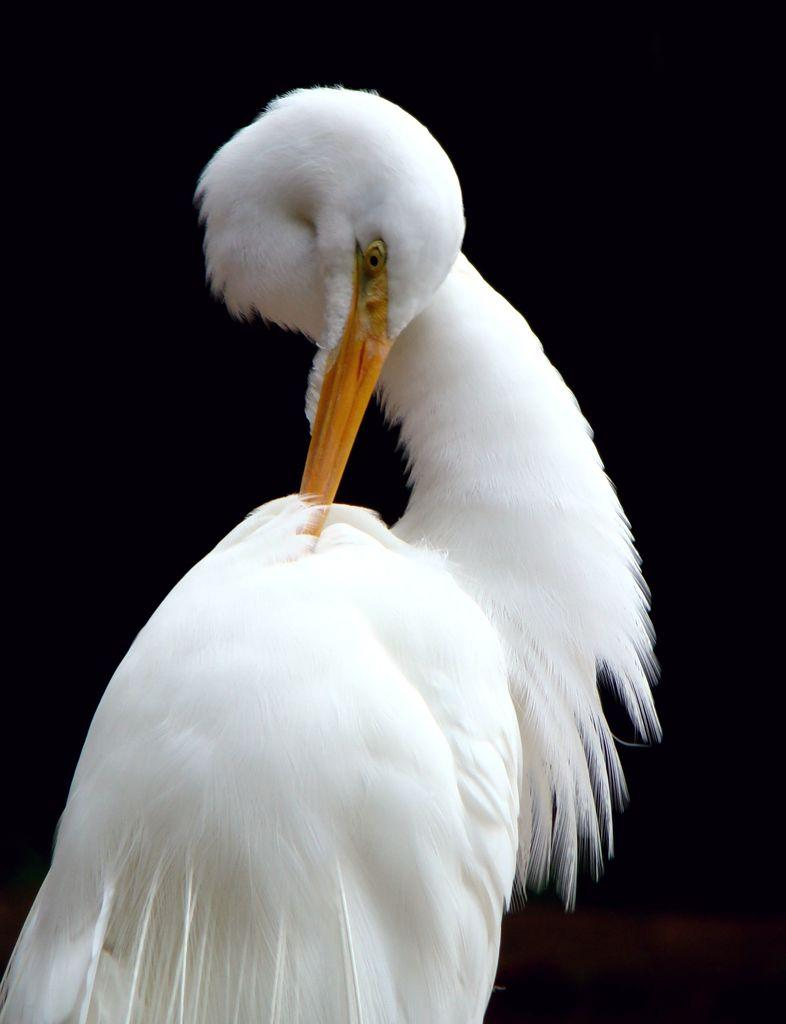What type of animal is present in the image? There is a bird in the image. Can you describe any specific features of the bird? The bird has a long beak. What type of potato is being used as a pet in the image? There is no potato or pet present in the image; it features a bird with a long beak. Is there a chain attached to the bird in the image? There is no chain present in the image; the bird is not shown to be restrained in any way. 